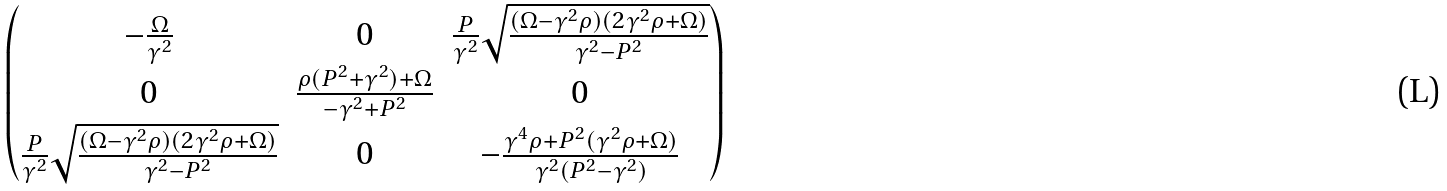<formula> <loc_0><loc_0><loc_500><loc_500>\begin{pmatrix} - \frac { \Omega } { \gamma ^ { 2 } } & 0 & \frac { P } { \gamma ^ { 2 } } \sqrt { \frac { ( \Omega - \gamma ^ { 2 } \rho ) ( 2 \gamma ^ { 2 } \rho + \Omega ) } { \gamma ^ { 2 } - P ^ { 2 } } } \\ 0 & \frac { \rho ( P ^ { 2 } + \gamma ^ { 2 } ) + \Omega } { - \gamma ^ { 2 } + P ^ { 2 } } & 0 \\ \frac { P } { \gamma ^ { 2 } } \sqrt { \frac { ( \Omega - \gamma ^ { 2 } \rho ) ( 2 \gamma ^ { 2 } \rho + \Omega ) } { \gamma ^ { 2 } - P ^ { 2 } } } & 0 & - \frac { \gamma ^ { 4 } \rho + P ^ { 2 } ( \gamma ^ { 2 } \rho + \Omega ) } { \gamma ^ { 2 } ( P ^ { 2 } - \gamma ^ { 2 } ) } \end{pmatrix}</formula> 